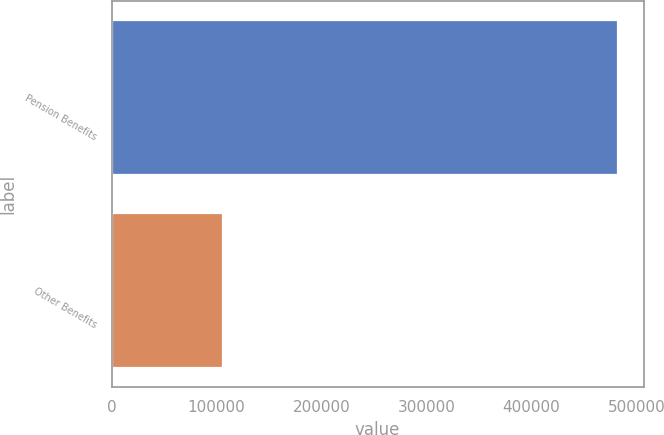<chart> <loc_0><loc_0><loc_500><loc_500><bar_chart><fcel>Pension Benefits<fcel>Other Benefits<nl><fcel>482861<fcel>106526<nl></chart> 